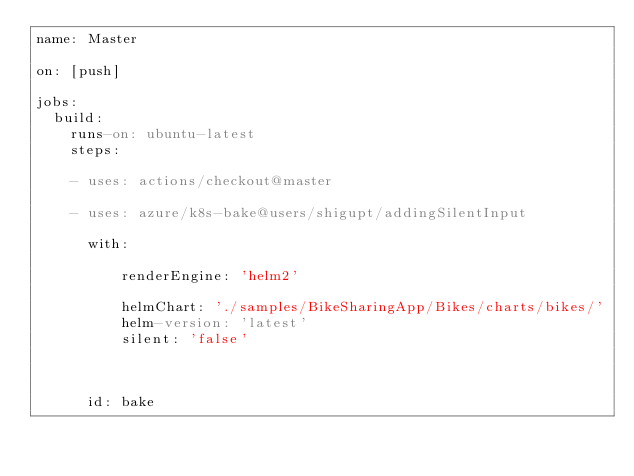Convert code to text. <code><loc_0><loc_0><loc_500><loc_500><_YAML_>name: Master

on: [push]
    
jobs:
  build:
    runs-on: ubuntu-latest
    steps:
    
    - uses: actions/checkout@master
     
    - uses: azure/k8s-bake@users/shigupt/addingSilentInput

      with:

          renderEngine: 'helm2'

          helmChart: './samples/BikeSharingApp/Bikes/charts/bikes/'             
          helm-version: 'latest'           
          silent: 'false'
                                                                                                
               
               
      id: bake
</code> 